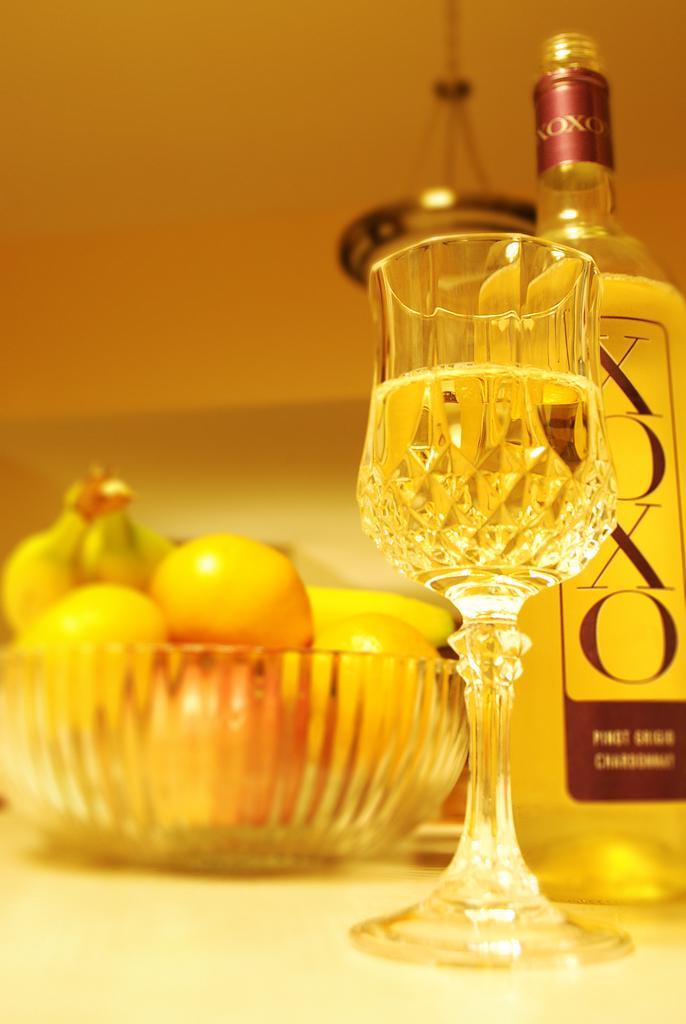In one or two sentences, can you explain what this image depicts? In this image I can see the bowl with fruits. To the side I can see the glass and the bottle. These are on the surface. In the background I can see an object and the wall. 